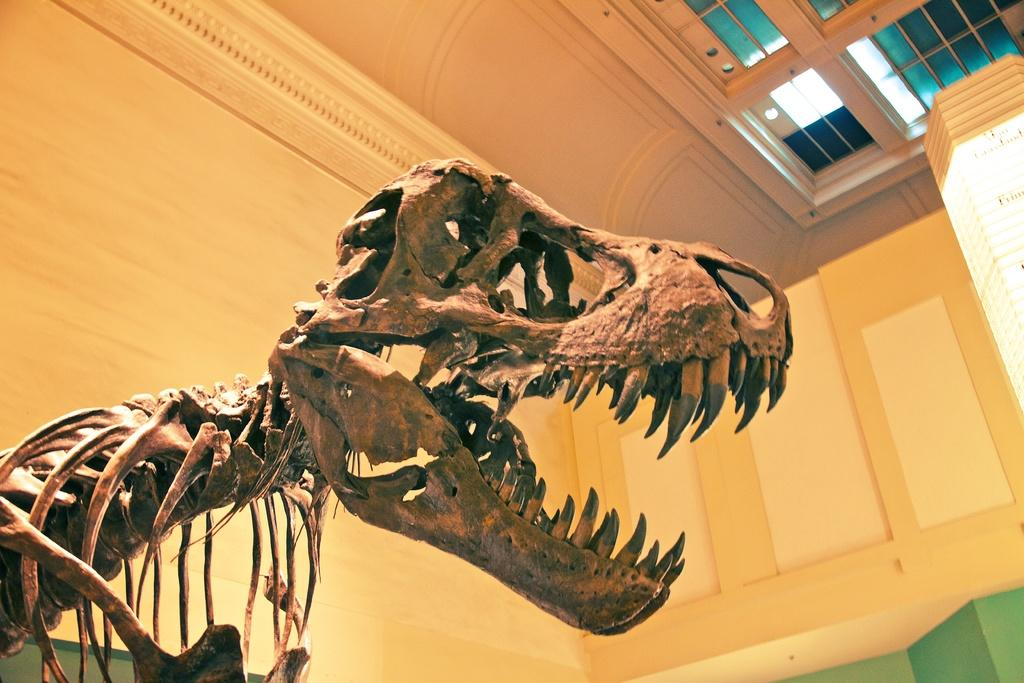What is the main subject of the image? There is an animal skeleton in the image. What can be seen in the background of the image? There is a wall in the background of the image. What is the glass element visible at the top of the image? It is not clear what the glass element is, but it is visible at the top of the image. What is the source of light in the image? There is a light source visible at the top of the image. What type of toothpaste is being used to clean the animal skeleton in the image? There is no toothpaste present in the image, and the animal skeleton is not being cleaned. 